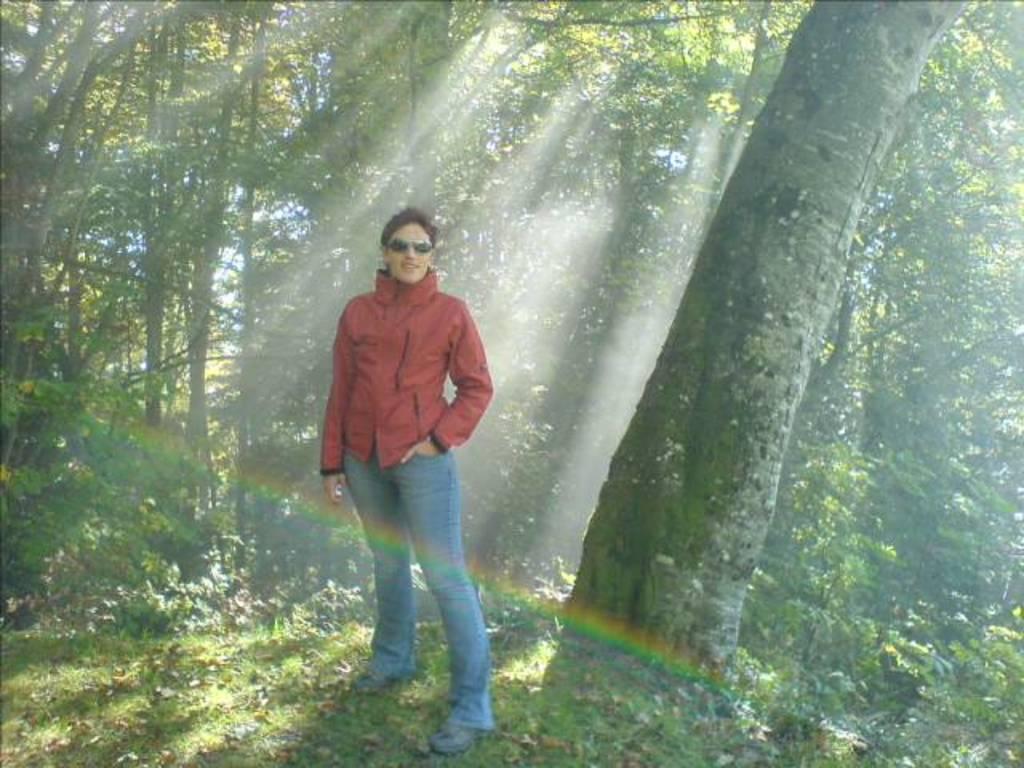How would you summarize this image in a sentence or two? In this picture there is a man who is wearing goggles, jacket, trouser and shoes. Besides him I can see the trees, plants and grass. Behind him I can see some sun's light beam. In the background I can see the sky. 